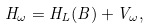<formula> <loc_0><loc_0><loc_500><loc_500>H _ { \omega } = H _ { L } ( B ) + V _ { \omega } ,</formula> 